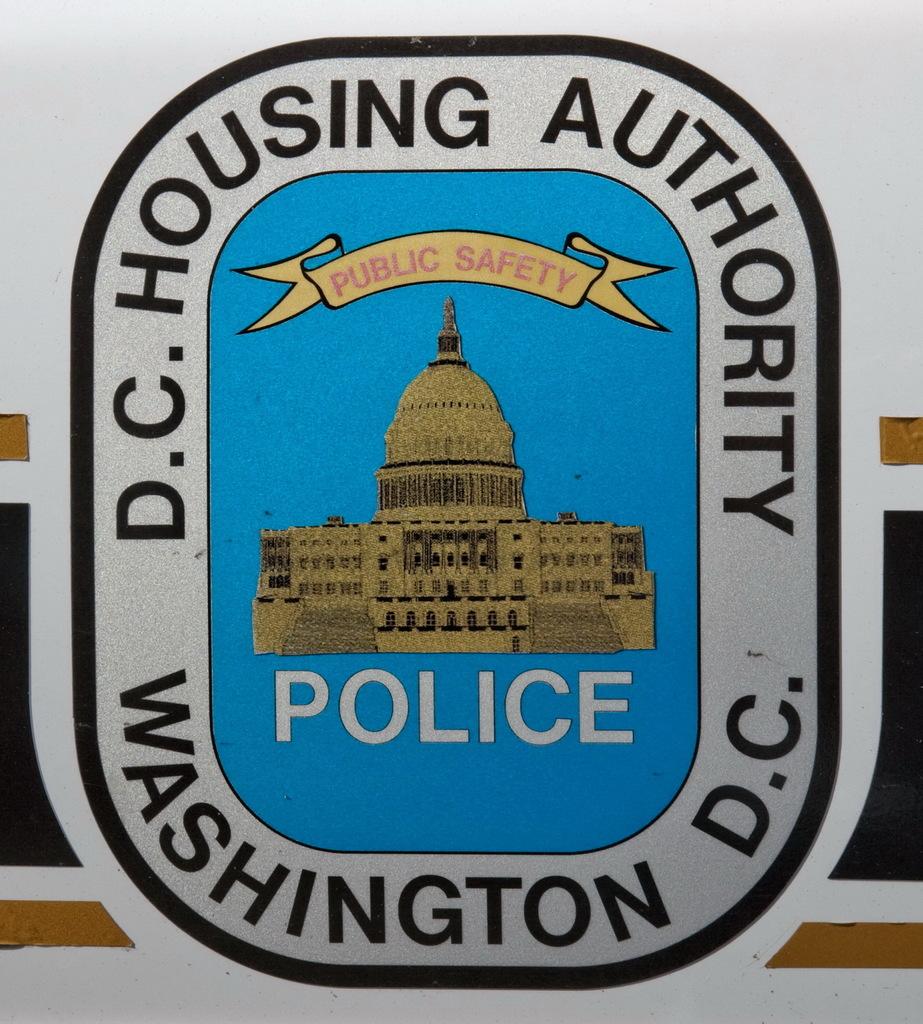What police department is this for?
Give a very brief answer. Dc housing authority. This is police station?
Keep it short and to the point. Yes. 